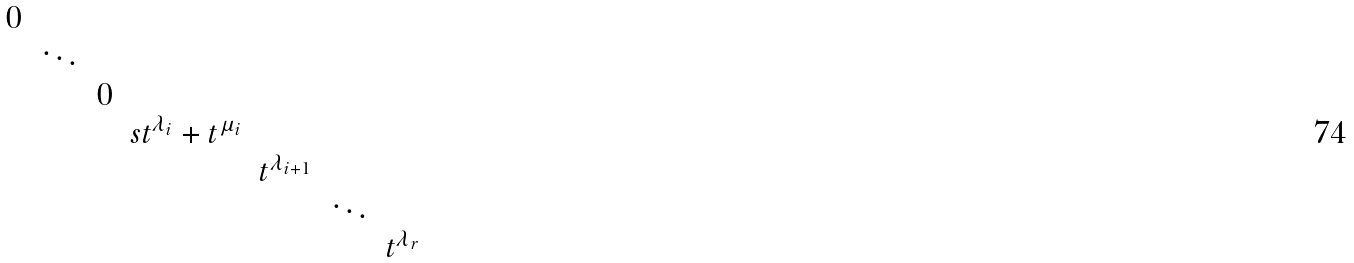Convert formula to latex. <formula><loc_0><loc_0><loc_500><loc_500>\begin{matrix} 0 \\ & \ddots \\ & & 0 \\ & & & s t ^ { \lambda _ { i } } + t ^ { \mu _ { i } } \\ & & & & t ^ { \lambda _ { i + 1 } } \\ & & & & & \ddots \\ & & & & & & t ^ { \lambda _ { r } } \end{matrix}</formula> 